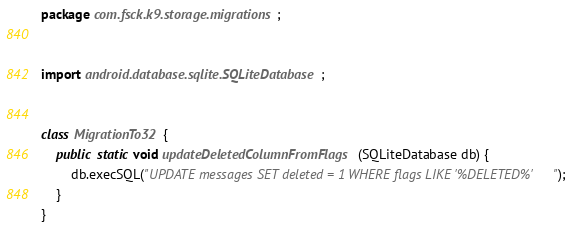Convert code to text. <code><loc_0><loc_0><loc_500><loc_500><_Java_>package com.fsck.k9.storage.migrations;


import android.database.sqlite.SQLiteDatabase;


class MigrationTo32 {
    public static void updateDeletedColumnFromFlags(SQLiteDatabase db) {
        db.execSQL("UPDATE messages SET deleted = 1 WHERE flags LIKE '%DELETED%'");
    }
}
</code> 